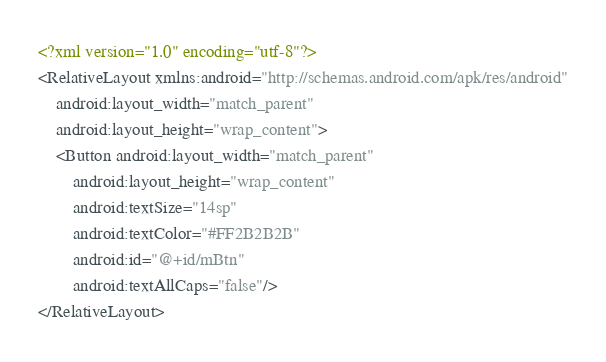<code> <loc_0><loc_0><loc_500><loc_500><_XML_><?xml version="1.0" encoding="utf-8"?>
<RelativeLayout xmlns:android="http://schemas.android.com/apk/res/android"
    android:layout_width="match_parent"
    android:layout_height="wrap_content">
    <Button android:layout_width="match_parent"
        android:layout_height="wrap_content"
        android:textSize="14sp"
        android:textColor="#FF2B2B2B"
        android:id="@+id/mBtn"
        android:textAllCaps="false"/>
</RelativeLayout></code> 